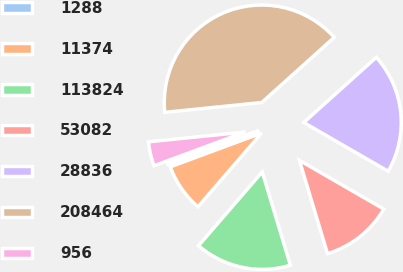Convert chart. <chart><loc_0><loc_0><loc_500><loc_500><pie_chart><fcel>1288<fcel>11374<fcel>113824<fcel>53082<fcel>28836<fcel>208464<fcel>956<nl><fcel>0.02%<fcel>8.01%<fcel>16.0%<fcel>12.0%<fcel>19.99%<fcel>39.96%<fcel>4.02%<nl></chart> 